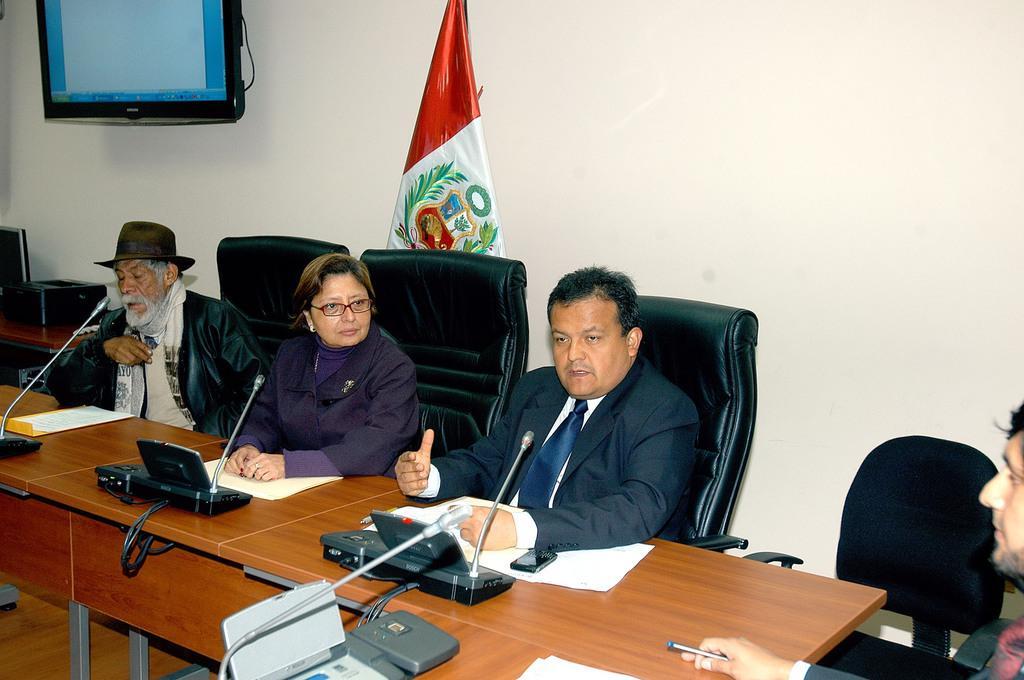Describe this image in one or two sentences. In the image there are four persons sitting on chairs in front of table with mic and laptops in front of them and behind there is a wall in front of them and there is a tv on the left side with a flag in the middle. 